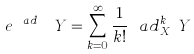Convert formula to latex. <formula><loc_0><loc_0><loc_500><loc_500>e ^ { \ a d _ { X _ { H } } } Y = \sum _ { k = 0 } ^ { \infty } \frac { 1 } { k ! } \ a d _ { X _ { H } } ^ { k } Y</formula> 